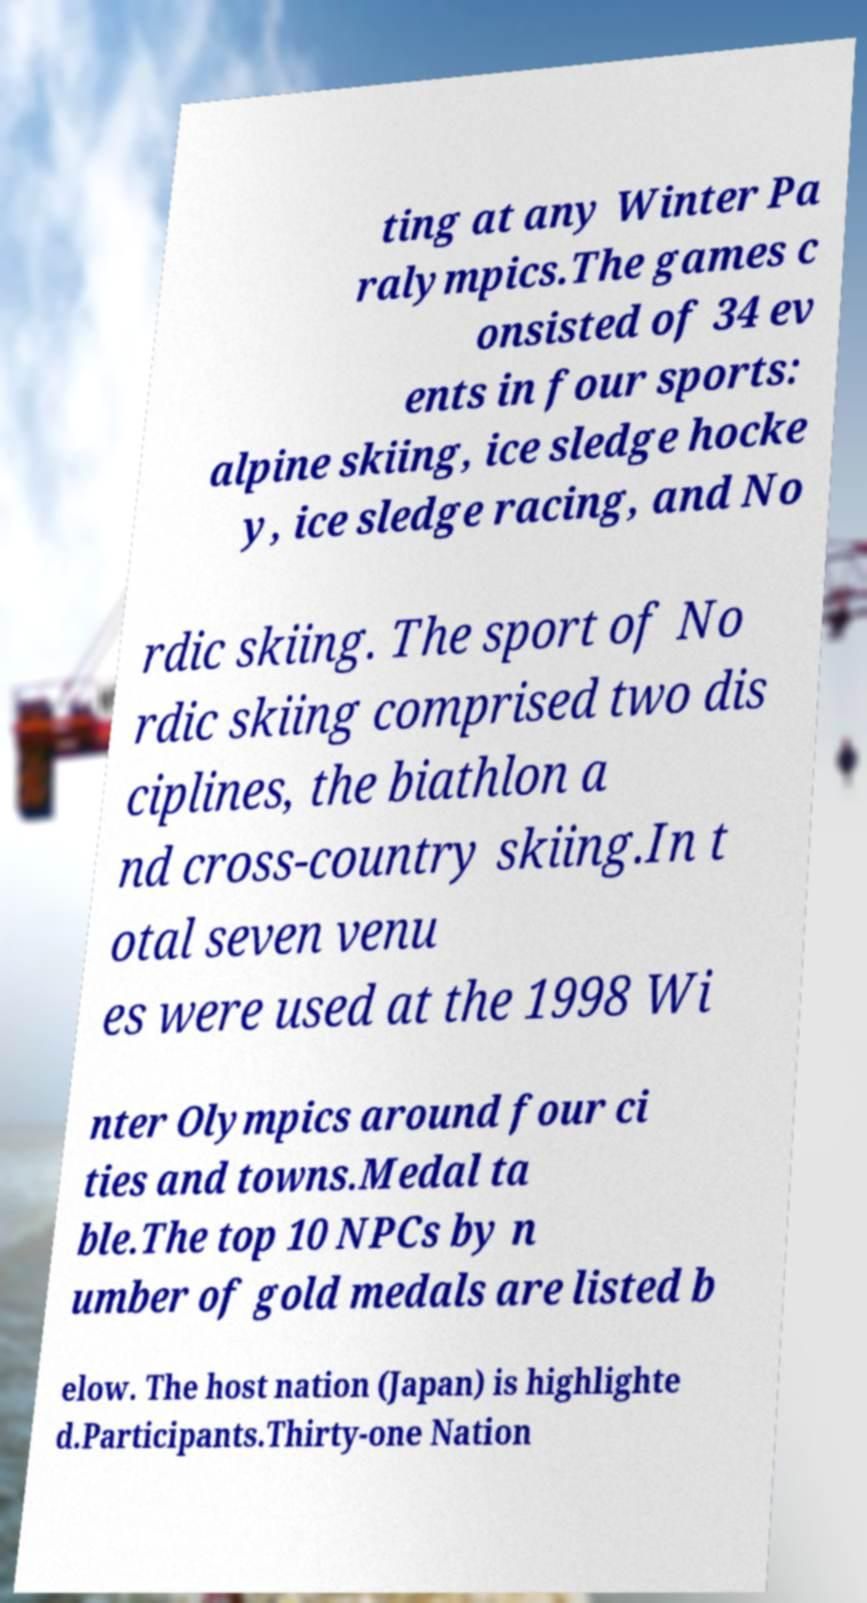There's text embedded in this image that I need extracted. Can you transcribe it verbatim? ting at any Winter Pa ralympics.The games c onsisted of 34 ev ents in four sports: alpine skiing, ice sledge hocke y, ice sledge racing, and No rdic skiing. The sport of No rdic skiing comprised two dis ciplines, the biathlon a nd cross-country skiing.In t otal seven venu es were used at the 1998 Wi nter Olympics around four ci ties and towns.Medal ta ble.The top 10 NPCs by n umber of gold medals are listed b elow. The host nation (Japan) is highlighte d.Participants.Thirty-one Nation 